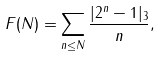<formula> <loc_0><loc_0><loc_500><loc_500>F ( N ) = \sum _ { n \leq N } \frac { | 2 ^ { n } - 1 | _ { 3 } } { n } ,</formula> 